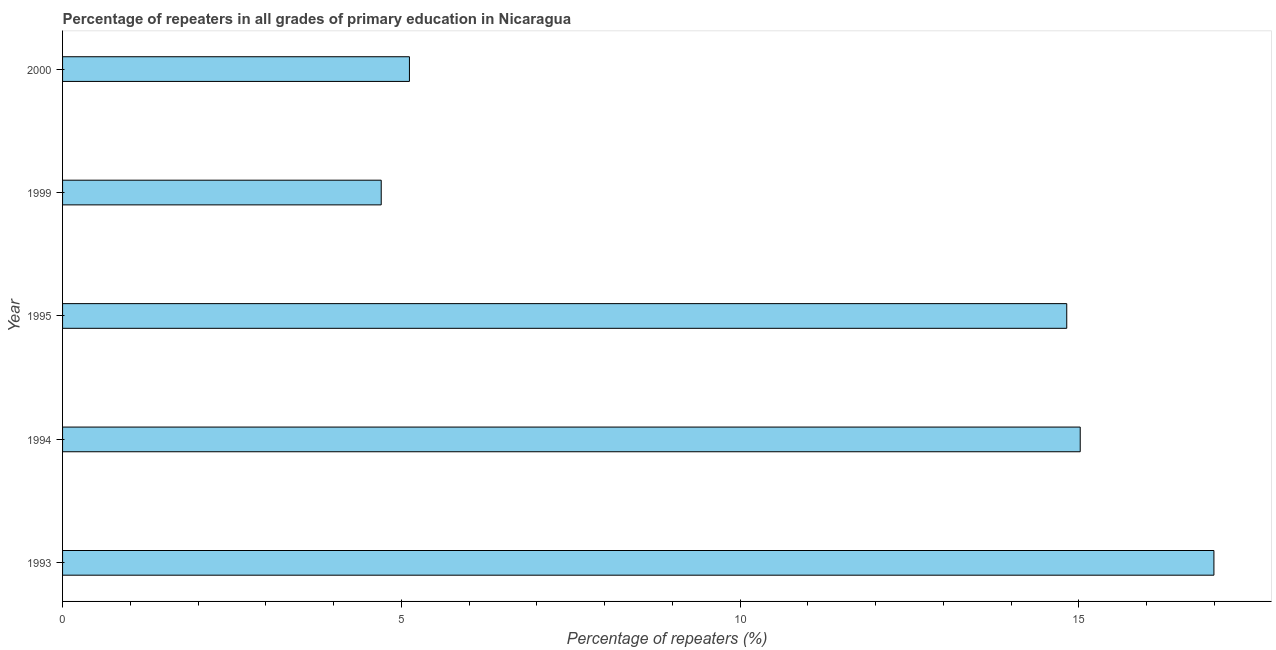Does the graph contain any zero values?
Your answer should be very brief. No. Does the graph contain grids?
Provide a succinct answer. No. What is the title of the graph?
Your response must be concise. Percentage of repeaters in all grades of primary education in Nicaragua. What is the label or title of the X-axis?
Keep it short and to the point. Percentage of repeaters (%). What is the label or title of the Y-axis?
Provide a short and direct response. Year. What is the percentage of repeaters in primary education in 2000?
Make the answer very short. 5.12. Across all years, what is the maximum percentage of repeaters in primary education?
Give a very brief answer. 16.99. Across all years, what is the minimum percentage of repeaters in primary education?
Your response must be concise. 4.7. In which year was the percentage of repeaters in primary education minimum?
Ensure brevity in your answer.  1999. What is the sum of the percentage of repeaters in primary education?
Make the answer very short. 56.65. What is the difference between the percentage of repeaters in primary education in 1994 and 1999?
Offer a terse response. 10.32. What is the average percentage of repeaters in primary education per year?
Offer a terse response. 11.33. What is the median percentage of repeaters in primary education?
Keep it short and to the point. 14.82. In how many years, is the percentage of repeaters in primary education greater than 14 %?
Offer a very short reply. 3. What is the ratio of the percentage of repeaters in primary education in 1993 to that in 1999?
Make the answer very short. 3.61. What is the difference between the highest and the second highest percentage of repeaters in primary education?
Your response must be concise. 1.97. Is the sum of the percentage of repeaters in primary education in 1993 and 2000 greater than the maximum percentage of repeaters in primary education across all years?
Make the answer very short. Yes. What is the difference between the highest and the lowest percentage of repeaters in primary education?
Your response must be concise. 12.29. In how many years, is the percentage of repeaters in primary education greater than the average percentage of repeaters in primary education taken over all years?
Provide a succinct answer. 3. How many bars are there?
Provide a succinct answer. 5. What is the difference between two consecutive major ticks on the X-axis?
Your answer should be very brief. 5. What is the Percentage of repeaters (%) in 1993?
Provide a short and direct response. 16.99. What is the Percentage of repeaters (%) in 1994?
Provide a succinct answer. 15.02. What is the Percentage of repeaters (%) in 1995?
Your answer should be compact. 14.82. What is the Percentage of repeaters (%) in 1999?
Your answer should be very brief. 4.7. What is the Percentage of repeaters (%) of 2000?
Give a very brief answer. 5.12. What is the difference between the Percentage of repeaters (%) in 1993 and 1994?
Your answer should be very brief. 1.97. What is the difference between the Percentage of repeaters (%) in 1993 and 1995?
Give a very brief answer. 2.17. What is the difference between the Percentage of repeaters (%) in 1993 and 1999?
Provide a succinct answer. 12.29. What is the difference between the Percentage of repeaters (%) in 1993 and 2000?
Keep it short and to the point. 11.87. What is the difference between the Percentage of repeaters (%) in 1994 and 1995?
Ensure brevity in your answer.  0.2. What is the difference between the Percentage of repeaters (%) in 1994 and 1999?
Your answer should be very brief. 10.32. What is the difference between the Percentage of repeaters (%) in 1994 and 2000?
Provide a succinct answer. 9.9. What is the difference between the Percentage of repeaters (%) in 1995 and 1999?
Provide a short and direct response. 10.12. What is the difference between the Percentage of repeaters (%) in 1995 and 2000?
Offer a very short reply. 9.7. What is the difference between the Percentage of repeaters (%) in 1999 and 2000?
Offer a terse response. -0.42. What is the ratio of the Percentage of repeaters (%) in 1993 to that in 1994?
Make the answer very short. 1.13. What is the ratio of the Percentage of repeaters (%) in 1993 to that in 1995?
Offer a terse response. 1.15. What is the ratio of the Percentage of repeaters (%) in 1993 to that in 1999?
Offer a very short reply. 3.61. What is the ratio of the Percentage of repeaters (%) in 1993 to that in 2000?
Keep it short and to the point. 3.32. What is the ratio of the Percentage of repeaters (%) in 1994 to that in 1995?
Keep it short and to the point. 1.01. What is the ratio of the Percentage of repeaters (%) in 1994 to that in 1999?
Ensure brevity in your answer.  3.19. What is the ratio of the Percentage of repeaters (%) in 1994 to that in 2000?
Your answer should be compact. 2.93. What is the ratio of the Percentage of repeaters (%) in 1995 to that in 1999?
Make the answer very short. 3.15. What is the ratio of the Percentage of repeaters (%) in 1995 to that in 2000?
Your answer should be compact. 2.9. What is the ratio of the Percentage of repeaters (%) in 1999 to that in 2000?
Make the answer very short. 0.92. 